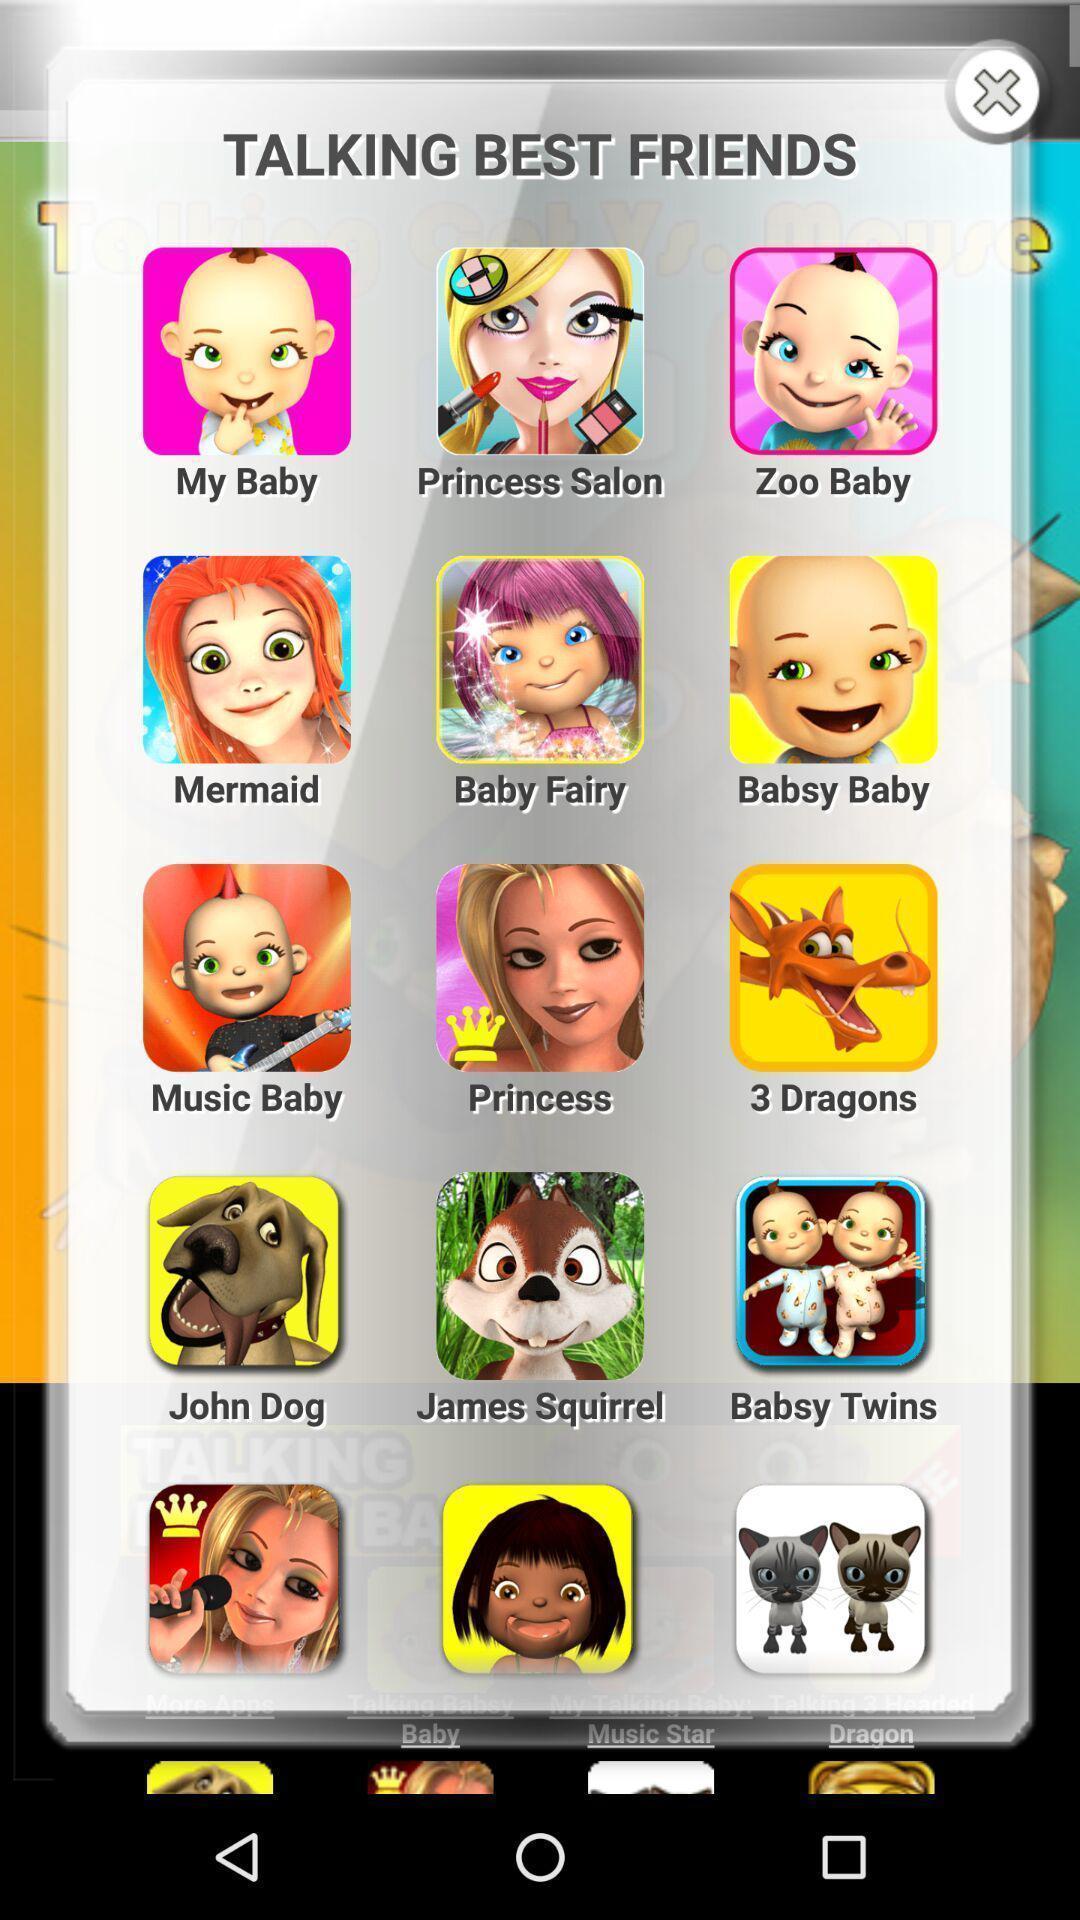Describe this image in words. Pop-up showing talking best friends in the app. 